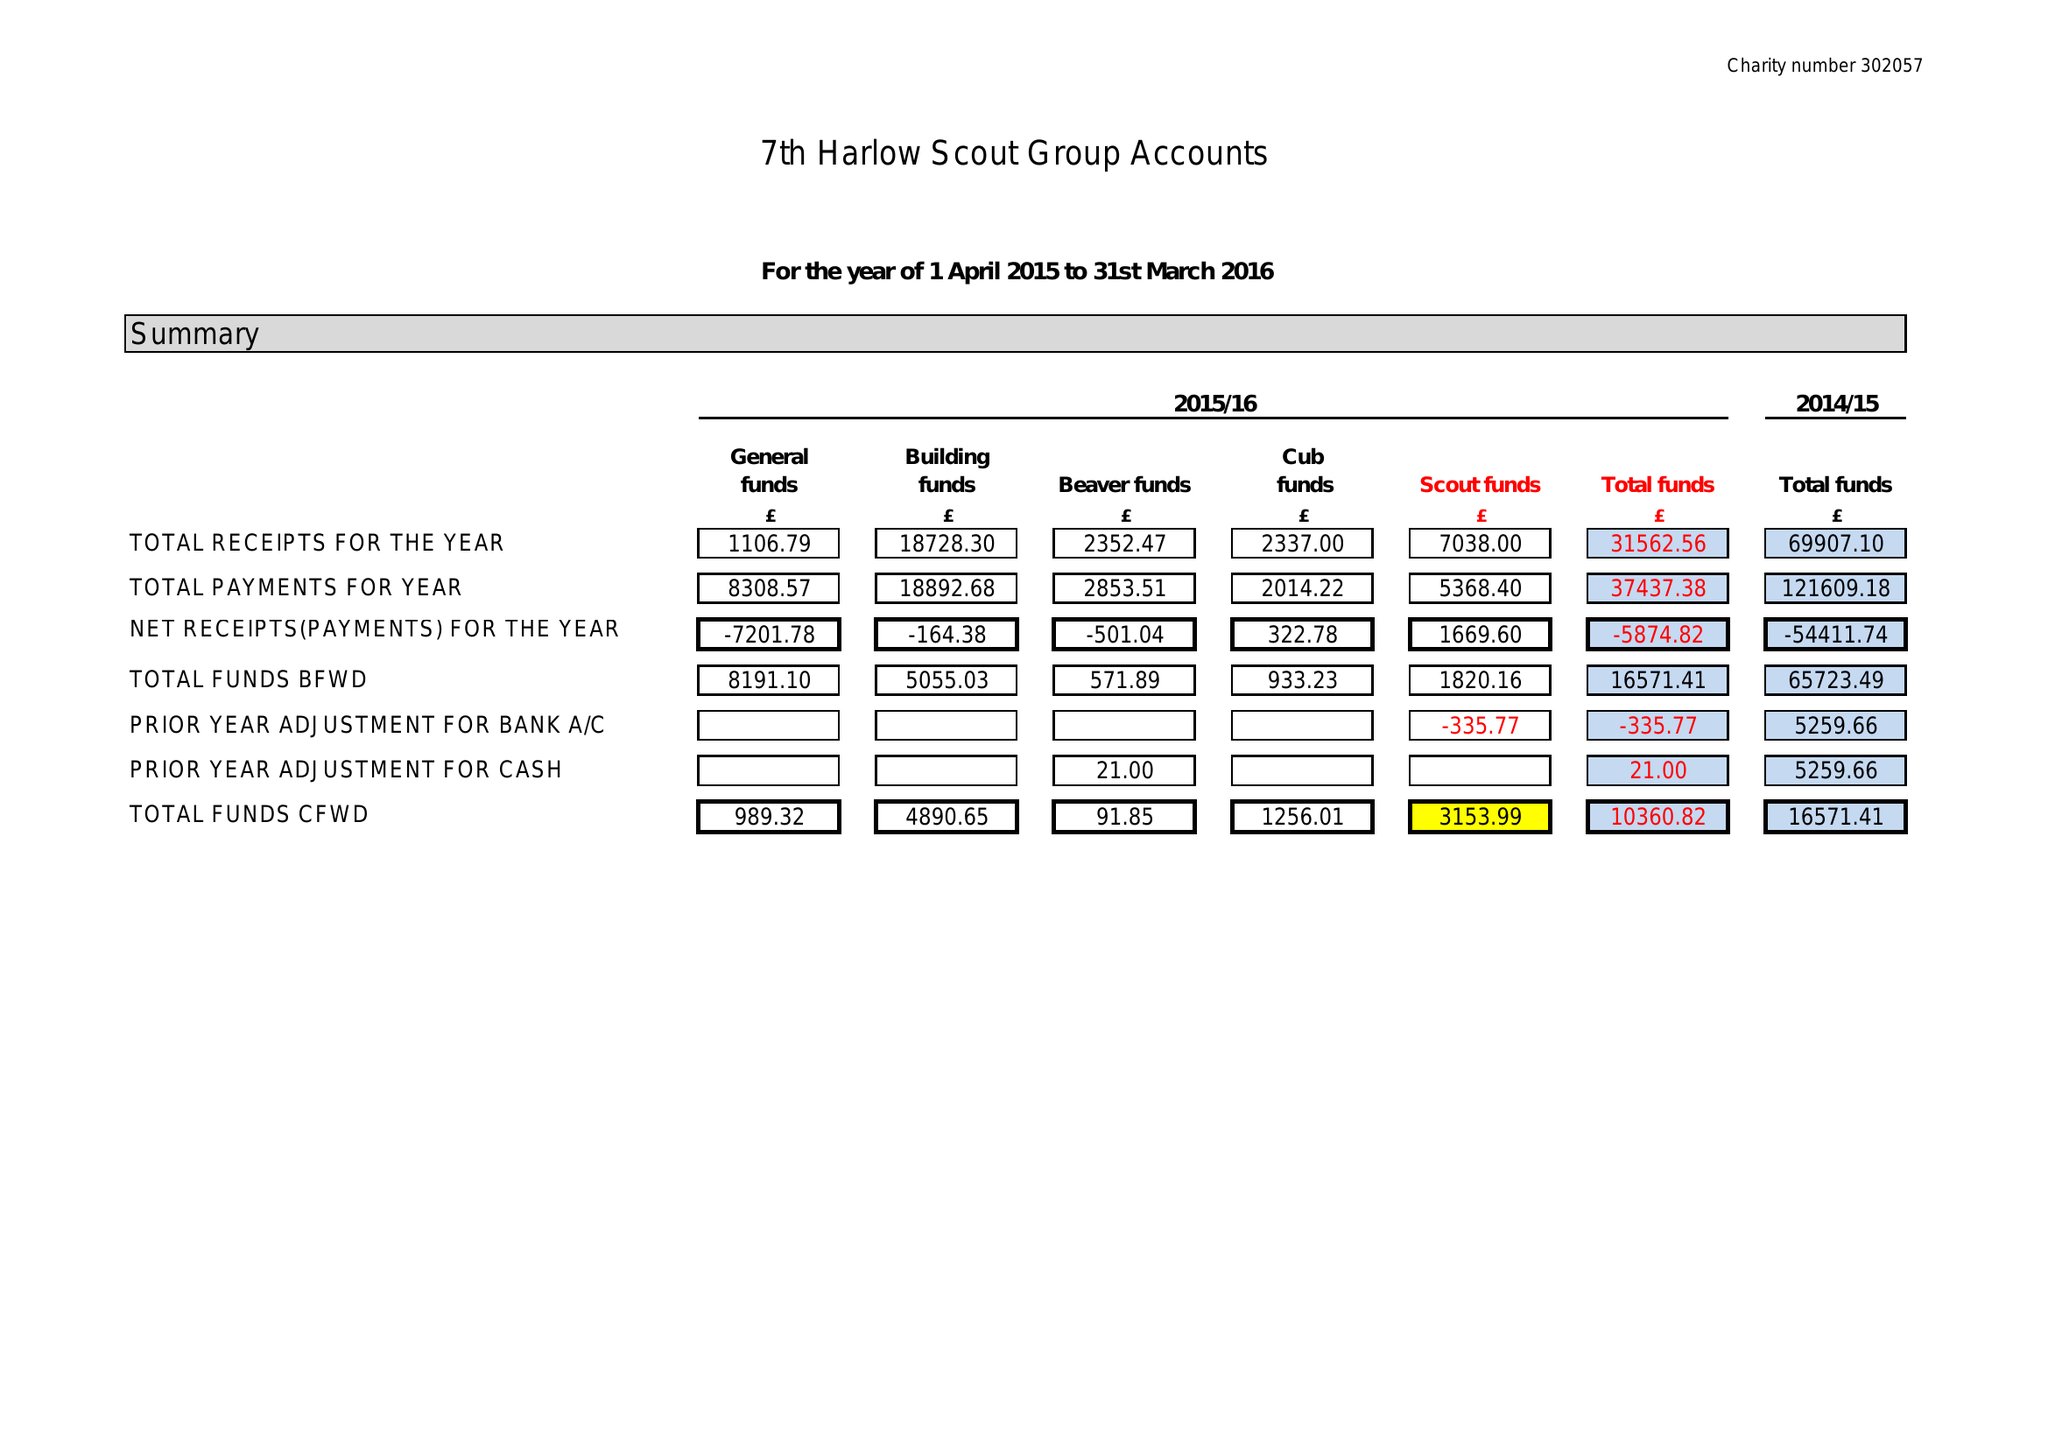What is the value for the income_annually_in_british_pounds?
Answer the question using a single word or phrase. 31563.00 